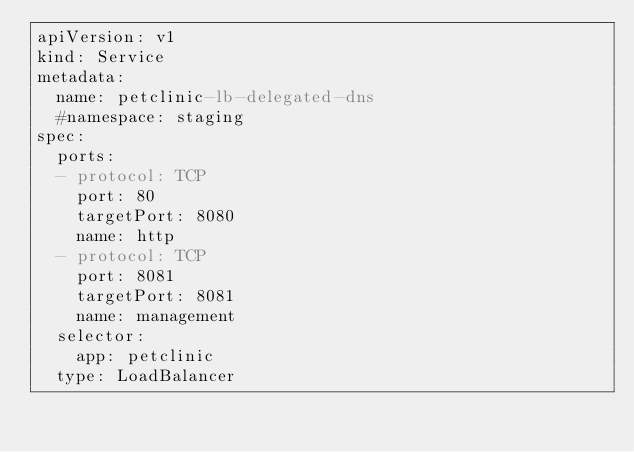Convert code to text. <code><loc_0><loc_0><loc_500><loc_500><_YAML_>apiVersion: v1
kind: Service
metadata:
  name: petclinic-lb-delegated-dns
  #namespace: staging
spec:
  ports:
  - protocol: TCP
    port: 80
    targetPort: 8080
    name: http  
  - protocol: TCP
    port: 8081
    targetPort: 8081
    name: management
  selector:
    app: petclinic
  type: LoadBalancer</code> 